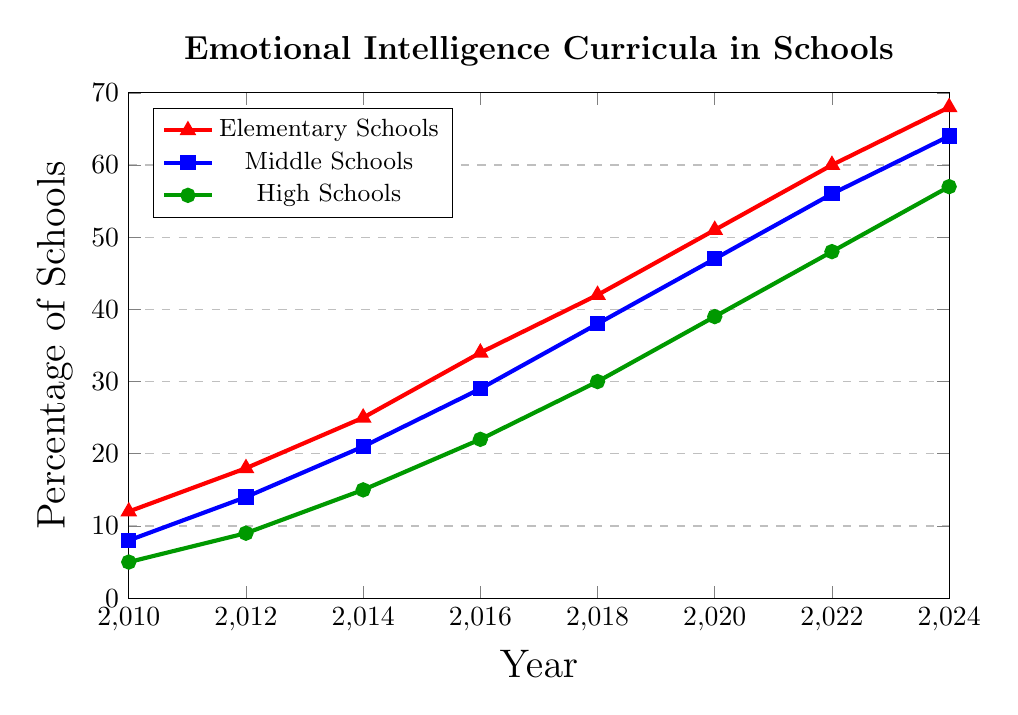Which grade level had the highest percentage of schools incorporating emotional intelligence curricula in 2022? To determine which grade level had the highest percentage in 2022, we look at the data points for 2022 for each school level: Elementary Schools (60%), Middle Schools (56%), and High Schools (48%). The highest percentage is for Elementary Schools.
Answer: Elementary Schools What is the difference in the percentage of schools incorporating emotional intelligence curricula between Middle Schools and High Schools in 2010? To find the difference, look at the percentage for Middle Schools (8%) and High Schools (5%) in 2010. The difference is 8% - 5% = 3%.
Answer: 3% How has the percentage of Elementary Schools incorporating emotional intelligence curricula changed from 2010 to 2024? We need to subtract the percentage in 2010 (12%) from the percentage in 2024 (68%). The change is 68% - 12% = 56%.
Answer: 56% Which grade level saw the largest increase in the percentage of schools incorporating emotional intelligence curricula from 2010 to 2024? For each grade level, find the percentage change from 2010 to 2024: 
    Elementary Schools: 68% - 12% = 56%
    Middle Schools: 64% - 8% = 56%
    High Schools: 57% - 5% = 52%
Both Elementary and Middle Schools saw the largest increase of 56%. Therefore, both Elementary and Middle Schools saw the largest increase.
Answer: Elementary Schools and Middle Schools In what year did the percentage of Elementary Schools incorporating emotional intelligence curricula surpass 50%? Looking at the percentage of Elementary Schools over the years, we see that it pastes 50% in 2020 (51%).
Answer: 2020 By how much did the percentage of High Schools incorporating emotional intelligence curricula increase from 2014 to 2020? To find the increase, subtract the percentage in 2014 (15%) from the percentage in 2020 (39%). The increase is 39% - 15% = 24%.
Answer: 24% What is the average percentage of Middle Schools incorporating emotional intelligence curricula in the years 2016, 2018, and 2020? We sum the percentages for Middle Schools in 2016, 2018, and 2020: 29% + 38% + 47% = 114%. Next, we divide by the number of years (3). The average is 114% / 3 = 38%.
Answer: 38% Compare the rate of increase in incorporating emotional intelligence curricula between Elementary and High Schools from 2018 to 2022. Which one had a higher rate? The rate of increase is calculated as (2022 value - 2018 value) / (2022 - 2018): 
    Elementary Schools: (60% - 42%) / 4 = 18% / 4 = 4.5% per year.
    High Schools: (48% - 30%) / 4 = 18% / 4 = 4.5% per year.
Both Elementary and High Schools had the same rate of 4.5% per year.
Answer: Both had the same rate Which school grade level had the lowest percentage increase in incorporating emotional intelligence curricula from 2022 to 2024? To find the lowest percentage increase from 2022 to 2024, calculate the increase for each:
    Elementary Schools: 68% - 60% = 8%. 
    Middle Schools: 64% - 56% = 8%.
    High Schools: 57% - 48% = 9%.
Elementary Schools and Middle Schools had the lowest increase of 8%.
Answer: Elementary Schools and Middle Schools 